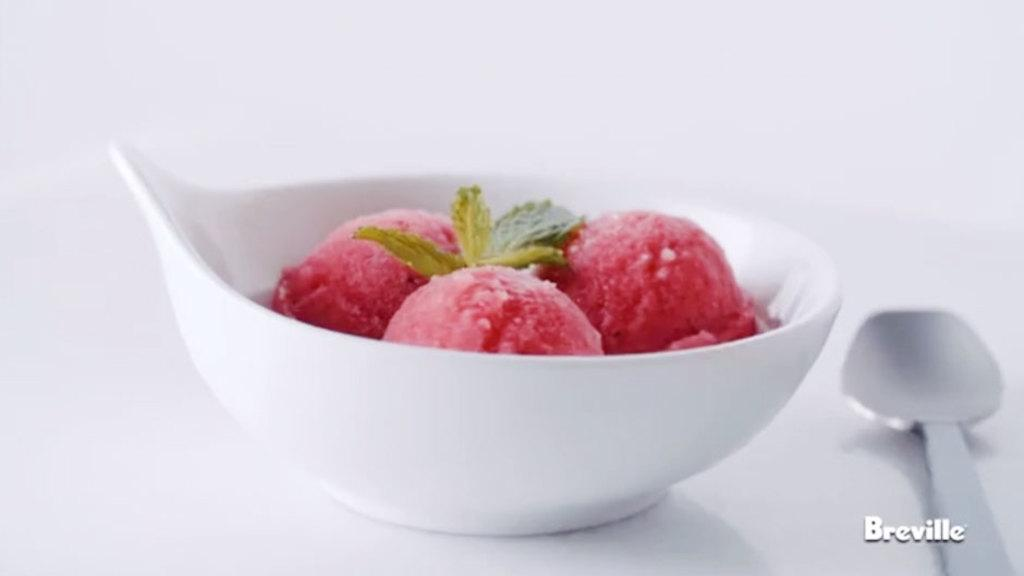What is in the bowl that is visible in the image? There is a bowl filled with ice cream in the image. Where is the bowl located in the image? The bowl is present on a table. What additional toppings are on the ice cream? There are mint leaves on the ice cream. What utensil is visible in the image? A spoon is visible in the image. What type of throne is present in the image? There is no throne present in the image; it features a bowl of ice cream on a table. Can you describe the toes of the person in the image? There is no person present in the image, so it is not possible to describe their toes. 